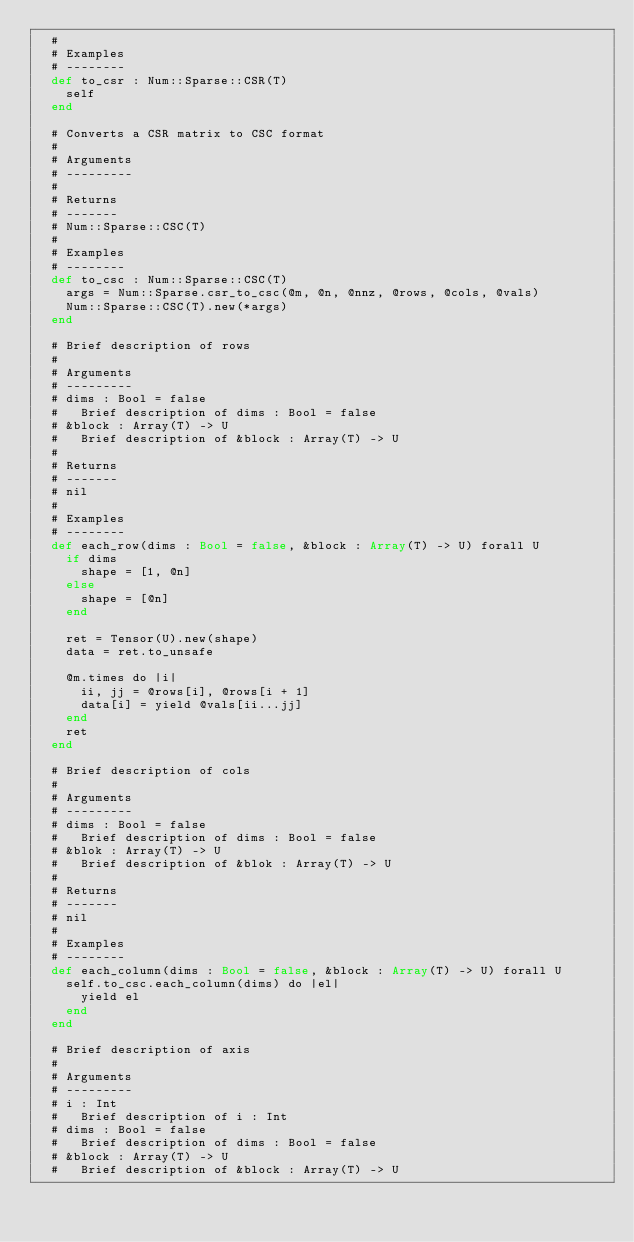Convert code to text. <code><loc_0><loc_0><loc_500><loc_500><_Crystal_>  #
  # Examples
  # --------
  def to_csr : Num::Sparse::CSR(T)
    self
  end

  # Converts a CSR matrix to CSC format
  #
  # Arguments
  # ---------
  #
  # Returns
  # -------
  # Num::Sparse::CSC(T)
  #
  # Examples
  # --------
  def to_csc : Num::Sparse::CSC(T)
    args = Num::Sparse.csr_to_csc(@m, @n, @nnz, @rows, @cols, @vals)
    Num::Sparse::CSC(T).new(*args)
  end

  # Brief description of rows
  #
  # Arguments
  # ---------
  # dims : Bool = false
  #   Brief description of dims : Bool = false
  # &block : Array(T) -> U
  #   Brief description of &block : Array(T) -> U
  #
  # Returns
  # -------
  # nil
  #
  # Examples
  # --------
  def each_row(dims : Bool = false, &block : Array(T) -> U) forall U
    if dims
      shape = [1, @n]
    else
      shape = [@n]
    end

    ret = Tensor(U).new(shape)
    data = ret.to_unsafe

    @m.times do |i|
      ii, jj = @rows[i], @rows[i + 1]
      data[i] = yield @vals[ii...jj]
    end
    ret
  end

  # Brief description of cols
  #
  # Arguments
  # ---------
  # dims : Bool = false
  #   Brief description of dims : Bool = false
  # &blok : Array(T) -> U
  #   Brief description of &blok : Array(T) -> U
  #
  # Returns
  # -------
  # nil
  #
  # Examples
  # --------
  def each_column(dims : Bool = false, &block : Array(T) -> U) forall U
    self.to_csc.each_column(dims) do |el|
      yield el
    end
  end

  # Brief description of axis
  #
  # Arguments
  # ---------
  # i : Int
  #   Brief description of i : Int
  # dims : Bool = false
  #   Brief description of dims : Bool = false
  # &block : Array(T) -> U
  #   Brief description of &block : Array(T) -> U</code> 